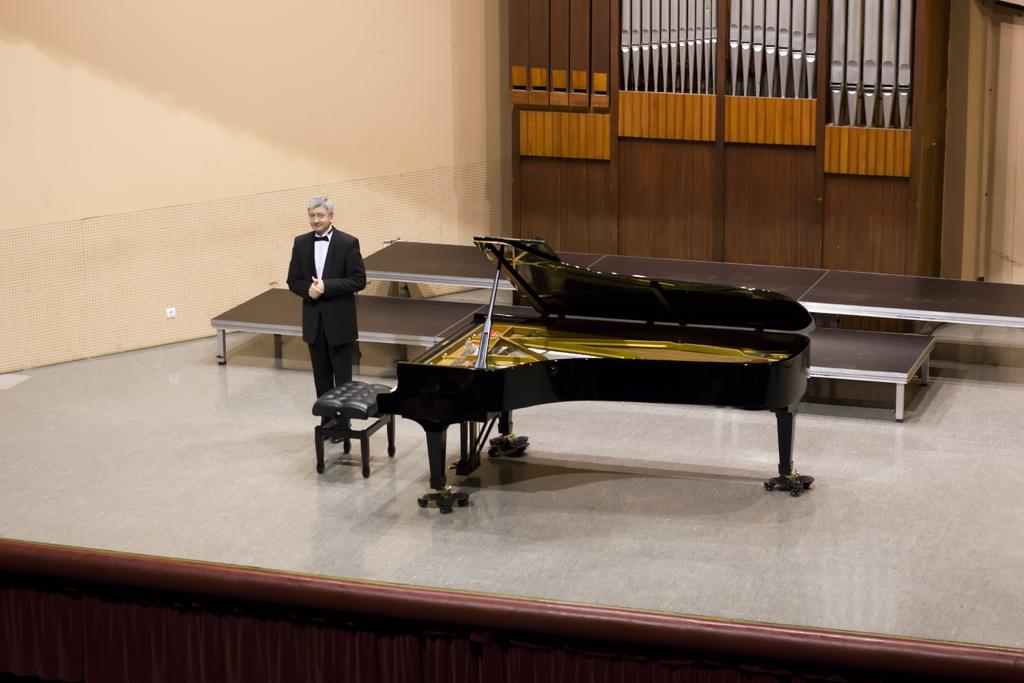What is the main subject of the image? There is a man standing in the image. Where is the man standing? The man is standing on the floor. What other objects can be seen in the image? There is a chair, a musical instrument, a wall in the background, and a door in the image. What type of insect is crawling on the man's shoulder in the image? There is no insect present on the man's shoulder in the image. Are the man's friends involved in a fight in the image? There is no fight or friends present in the image; it only shows a man standing with other objects. 